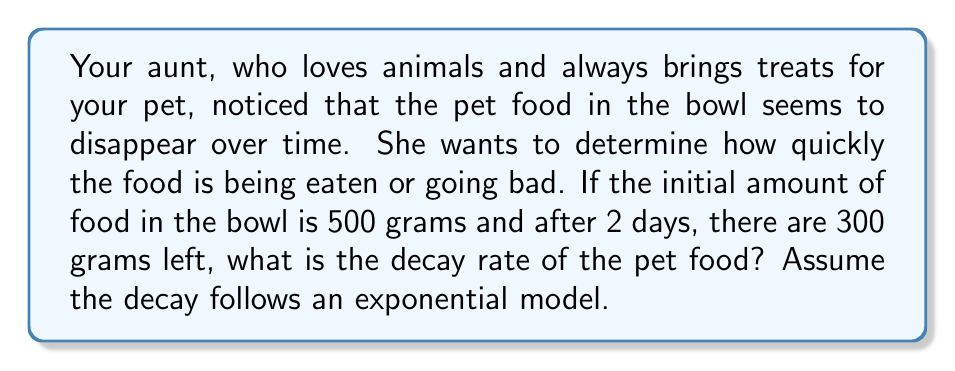Can you answer this question? Let's approach this step-by-step:

1) The exponential decay model is given by the equation:
   
   $A(t) = A_0 e^{-kt}$

   Where:
   $A(t)$ is the amount at time $t$
   $A_0$ is the initial amount
   $k$ is the decay rate
   $t$ is the time

2) We know:
   $A_0 = 500$ grams (initial amount)
   $A(2) = 300$ grams (amount after 2 days)
   $t = 2$ days

3) Let's plug these values into our equation:

   $300 = 500 e^{-k(2)}$

4) Divide both sides by 500:

   $\frac{300}{500} = e^{-2k}$

5) Take the natural log of both sides:

   $\ln(\frac{3}{5}) = -2k$

6) Solve for $k$:

   $k = -\frac{1}{2}\ln(\frac{3}{5})$

7) Calculate the value:

   $k = -\frac{1}{2}\ln(0.6) \approx 0.2554$

This decay rate is per day, as we used 2 days in our calculation.
Answer: The decay rate of the pet food is approximately 0.2554 per day. 